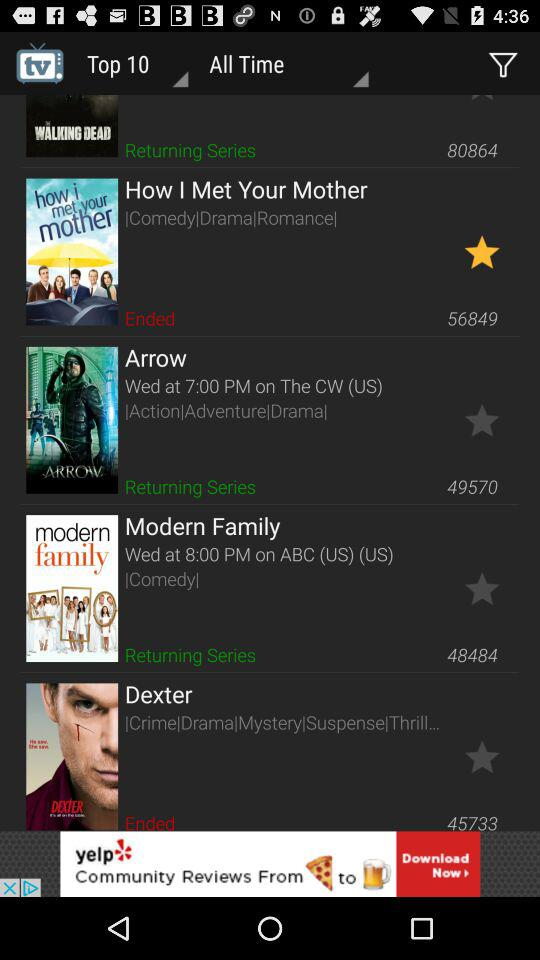What type of series is "How I Met Your Mother"? "How I Met Your Mother" is comedy, drama and romance series. 